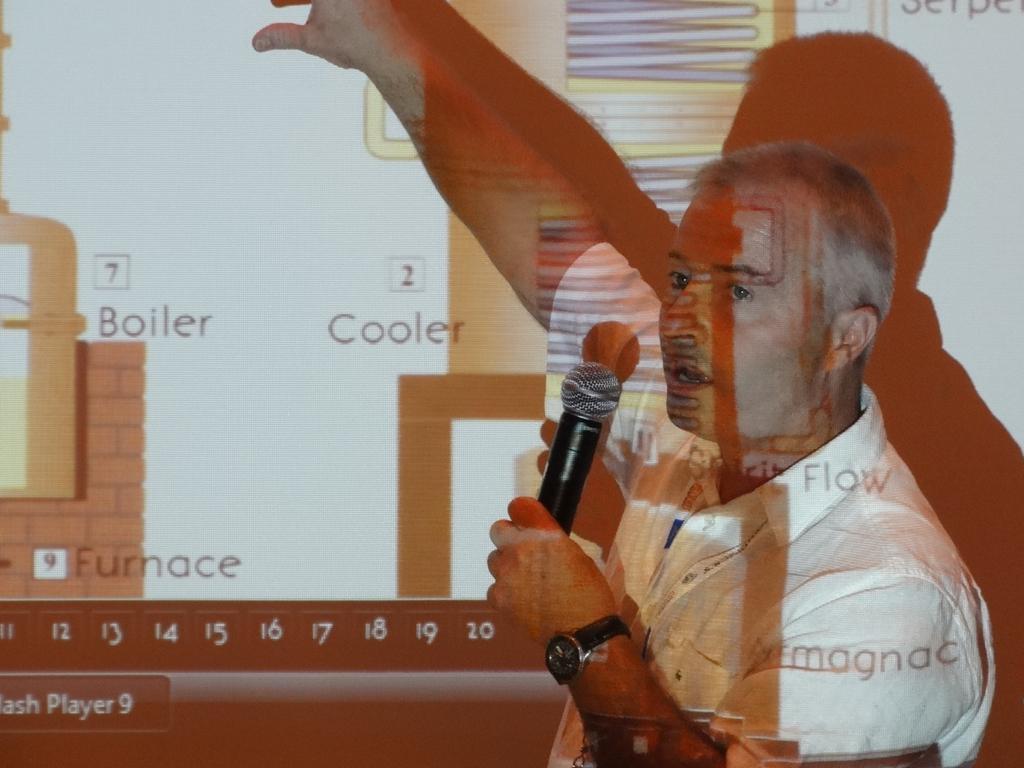Please provide a concise description of this image. A person is talking on mic by explaining the thing on the screen. 